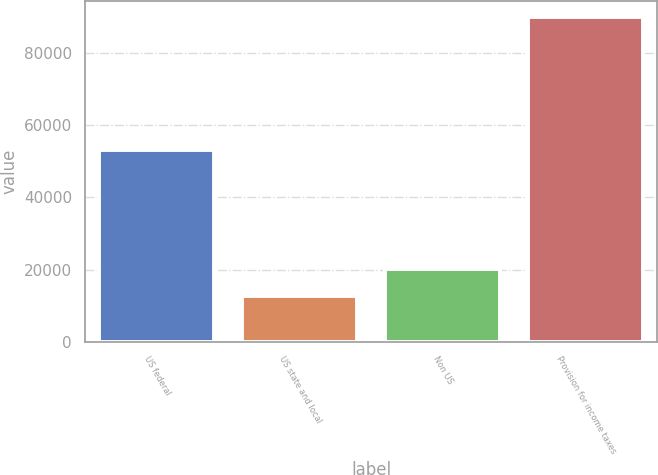Convert chart. <chart><loc_0><loc_0><loc_500><loc_500><bar_chart><fcel>US federal<fcel>US state and local<fcel>Non US<fcel>Provision for income taxes<nl><fcel>53041<fcel>12573<fcel>20311.6<fcel>89959<nl></chart> 